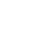Convert code to text. <code><loc_0><loc_0><loc_500><loc_500><_C_>
</code> 